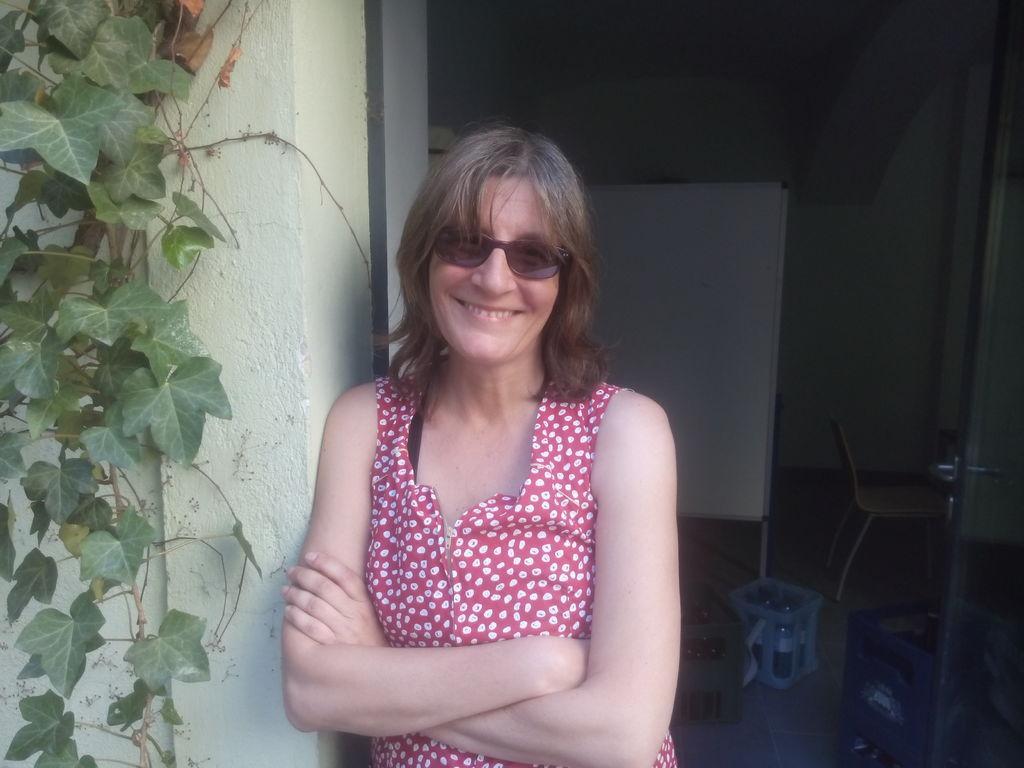Can you describe this image briefly? In the center of the image we can see woman standing at the wall. On the left side of the image there is a creeper. In the background there is a chair, board and wall. 